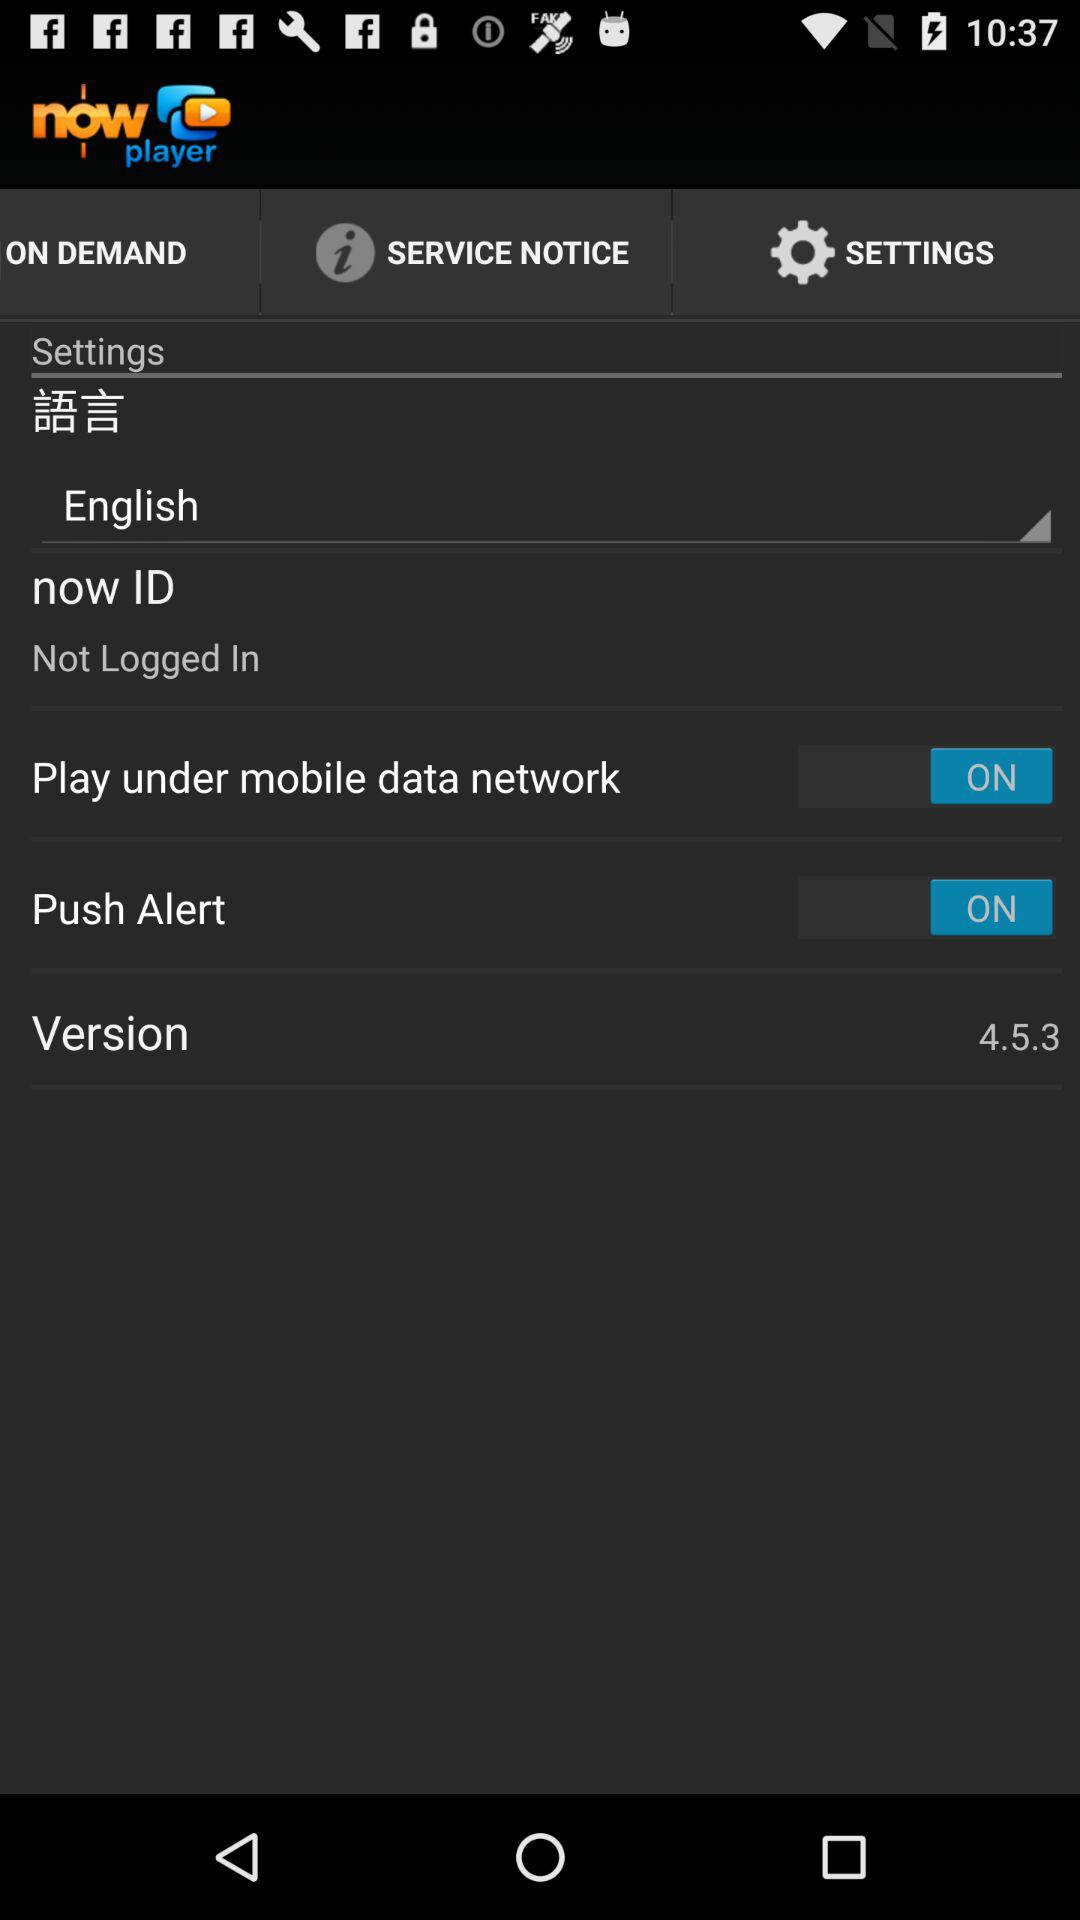What is the status of "Push Alert"? The status is "on". 